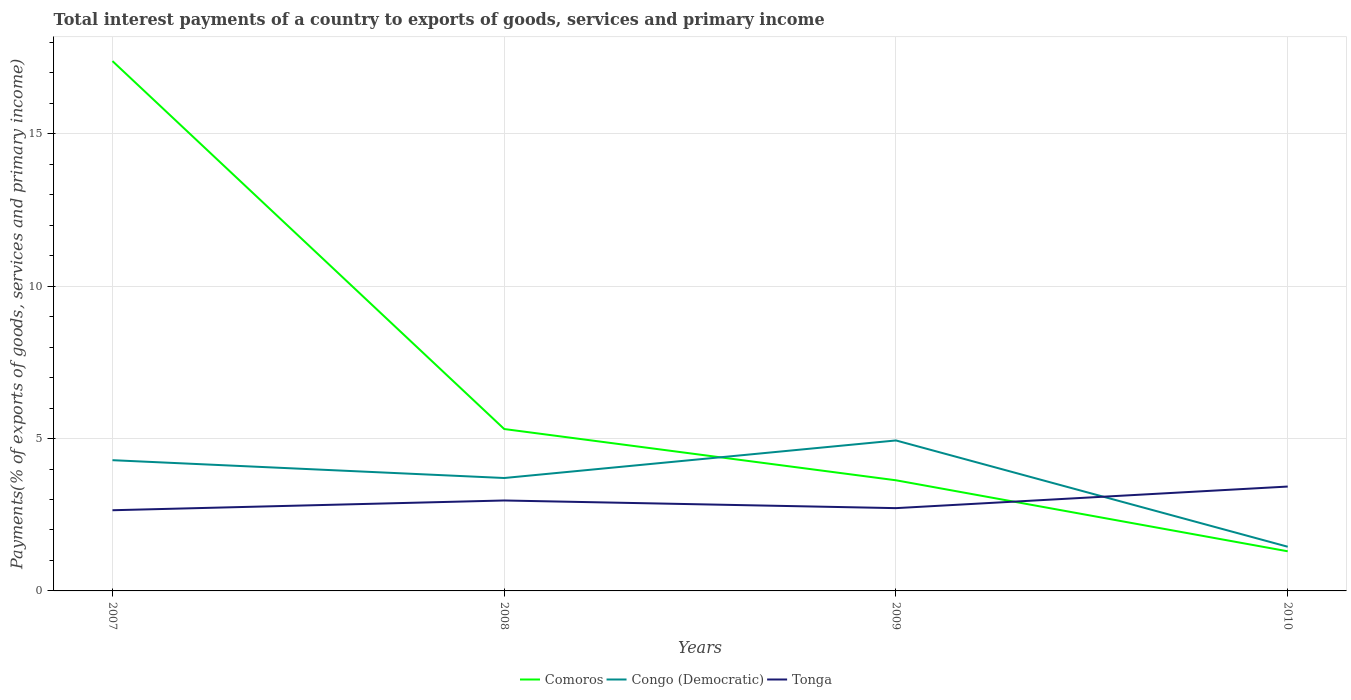How many different coloured lines are there?
Your response must be concise. 3. Is the number of lines equal to the number of legend labels?
Keep it short and to the point. Yes. Across all years, what is the maximum total interest payments in Congo (Democratic)?
Make the answer very short. 1.45. What is the total total interest payments in Comoros in the graph?
Your response must be concise. 4.01. What is the difference between the highest and the second highest total interest payments in Comoros?
Offer a very short reply. 16.09. Is the total interest payments in Tonga strictly greater than the total interest payments in Comoros over the years?
Your answer should be very brief. No. How many years are there in the graph?
Make the answer very short. 4. What is the difference between two consecutive major ticks on the Y-axis?
Keep it short and to the point. 5. Does the graph contain any zero values?
Ensure brevity in your answer.  No. How are the legend labels stacked?
Make the answer very short. Horizontal. What is the title of the graph?
Provide a short and direct response. Total interest payments of a country to exports of goods, services and primary income. Does "Yemen, Rep." appear as one of the legend labels in the graph?
Your answer should be very brief. No. What is the label or title of the X-axis?
Provide a succinct answer. Years. What is the label or title of the Y-axis?
Your answer should be compact. Payments(% of exports of goods, services and primary income). What is the Payments(% of exports of goods, services and primary income) in Comoros in 2007?
Ensure brevity in your answer.  17.39. What is the Payments(% of exports of goods, services and primary income) in Congo (Democratic) in 2007?
Give a very brief answer. 4.29. What is the Payments(% of exports of goods, services and primary income) of Tonga in 2007?
Give a very brief answer. 2.65. What is the Payments(% of exports of goods, services and primary income) in Comoros in 2008?
Offer a terse response. 5.31. What is the Payments(% of exports of goods, services and primary income) of Congo (Democratic) in 2008?
Provide a short and direct response. 3.71. What is the Payments(% of exports of goods, services and primary income) of Tonga in 2008?
Your answer should be very brief. 2.97. What is the Payments(% of exports of goods, services and primary income) of Comoros in 2009?
Your answer should be very brief. 3.63. What is the Payments(% of exports of goods, services and primary income) in Congo (Democratic) in 2009?
Your answer should be compact. 4.94. What is the Payments(% of exports of goods, services and primary income) in Tonga in 2009?
Make the answer very short. 2.72. What is the Payments(% of exports of goods, services and primary income) of Comoros in 2010?
Offer a terse response. 1.3. What is the Payments(% of exports of goods, services and primary income) in Congo (Democratic) in 2010?
Your response must be concise. 1.45. What is the Payments(% of exports of goods, services and primary income) of Tonga in 2010?
Your answer should be very brief. 3.43. Across all years, what is the maximum Payments(% of exports of goods, services and primary income) of Comoros?
Keep it short and to the point. 17.39. Across all years, what is the maximum Payments(% of exports of goods, services and primary income) of Congo (Democratic)?
Your answer should be compact. 4.94. Across all years, what is the maximum Payments(% of exports of goods, services and primary income) in Tonga?
Your response must be concise. 3.43. Across all years, what is the minimum Payments(% of exports of goods, services and primary income) of Comoros?
Make the answer very short. 1.3. Across all years, what is the minimum Payments(% of exports of goods, services and primary income) of Congo (Democratic)?
Offer a terse response. 1.45. Across all years, what is the minimum Payments(% of exports of goods, services and primary income) of Tonga?
Make the answer very short. 2.65. What is the total Payments(% of exports of goods, services and primary income) in Comoros in the graph?
Provide a succinct answer. 27.63. What is the total Payments(% of exports of goods, services and primary income) of Congo (Democratic) in the graph?
Provide a short and direct response. 14.38. What is the total Payments(% of exports of goods, services and primary income) in Tonga in the graph?
Ensure brevity in your answer.  11.76. What is the difference between the Payments(% of exports of goods, services and primary income) of Comoros in 2007 and that in 2008?
Your response must be concise. 12.07. What is the difference between the Payments(% of exports of goods, services and primary income) in Congo (Democratic) in 2007 and that in 2008?
Your answer should be very brief. 0.58. What is the difference between the Payments(% of exports of goods, services and primary income) of Tonga in 2007 and that in 2008?
Offer a terse response. -0.32. What is the difference between the Payments(% of exports of goods, services and primary income) in Comoros in 2007 and that in 2009?
Keep it short and to the point. 13.76. What is the difference between the Payments(% of exports of goods, services and primary income) of Congo (Democratic) in 2007 and that in 2009?
Keep it short and to the point. -0.65. What is the difference between the Payments(% of exports of goods, services and primary income) in Tonga in 2007 and that in 2009?
Make the answer very short. -0.07. What is the difference between the Payments(% of exports of goods, services and primary income) of Comoros in 2007 and that in 2010?
Your answer should be compact. 16.09. What is the difference between the Payments(% of exports of goods, services and primary income) in Congo (Democratic) in 2007 and that in 2010?
Your answer should be compact. 2.84. What is the difference between the Payments(% of exports of goods, services and primary income) of Tonga in 2007 and that in 2010?
Offer a terse response. -0.78. What is the difference between the Payments(% of exports of goods, services and primary income) in Comoros in 2008 and that in 2009?
Ensure brevity in your answer.  1.68. What is the difference between the Payments(% of exports of goods, services and primary income) in Congo (Democratic) in 2008 and that in 2009?
Your answer should be very brief. -1.23. What is the difference between the Payments(% of exports of goods, services and primary income) of Tonga in 2008 and that in 2009?
Your answer should be compact. 0.25. What is the difference between the Payments(% of exports of goods, services and primary income) of Comoros in 2008 and that in 2010?
Provide a short and direct response. 4.01. What is the difference between the Payments(% of exports of goods, services and primary income) in Congo (Democratic) in 2008 and that in 2010?
Offer a very short reply. 2.26. What is the difference between the Payments(% of exports of goods, services and primary income) of Tonga in 2008 and that in 2010?
Your response must be concise. -0.46. What is the difference between the Payments(% of exports of goods, services and primary income) of Comoros in 2009 and that in 2010?
Make the answer very short. 2.33. What is the difference between the Payments(% of exports of goods, services and primary income) of Congo (Democratic) in 2009 and that in 2010?
Your answer should be very brief. 3.49. What is the difference between the Payments(% of exports of goods, services and primary income) of Tonga in 2009 and that in 2010?
Provide a short and direct response. -0.71. What is the difference between the Payments(% of exports of goods, services and primary income) in Comoros in 2007 and the Payments(% of exports of goods, services and primary income) in Congo (Democratic) in 2008?
Your response must be concise. 13.68. What is the difference between the Payments(% of exports of goods, services and primary income) of Comoros in 2007 and the Payments(% of exports of goods, services and primary income) of Tonga in 2008?
Make the answer very short. 14.42. What is the difference between the Payments(% of exports of goods, services and primary income) of Congo (Democratic) in 2007 and the Payments(% of exports of goods, services and primary income) of Tonga in 2008?
Make the answer very short. 1.32. What is the difference between the Payments(% of exports of goods, services and primary income) of Comoros in 2007 and the Payments(% of exports of goods, services and primary income) of Congo (Democratic) in 2009?
Offer a very short reply. 12.45. What is the difference between the Payments(% of exports of goods, services and primary income) of Comoros in 2007 and the Payments(% of exports of goods, services and primary income) of Tonga in 2009?
Offer a very short reply. 14.67. What is the difference between the Payments(% of exports of goods, services and primary income) of Congo (Democratic) in 2007 and the Payments(% of exports of goods, services and primary income) of Tonga in 2009?
Provide a short and direct response. 1.57. What is the difference between the Payments(% of exports of goods, services and primary income) of Comoros in 2007 and the Payments(% of exports of goods, services and primary income) of Congo (Democratic) in 2010?
Provide a succinct answer. 15.94. What is the difference between the Payments(% of exports of goods, services and primary income) in Comoros in 2007 and the Payments(% of exports of goods, services and primary income) in Tonga in 2010?
Provide a short and direct response. 13.96. What is the difference between the Payments(% of exports of goods, services and primary income) of Congo (Democratic) in 2007 and the Payments(% of exports of goods, services and primary income) of Tonga in 2010?
Offer a terse response. 0.87. What is the difference between the Payments(% of exports of goods, services and primary income) in Comoros in 2008 and the Payments(% of exports of goods, services and primary income) in Congo (Democratic) in 2009?
Provide a succinct answer. 0.37. What is the difference between the Payments(% of exports of goods, services and primary income) of Comoros in 2008 and the Payments(% of exports of goods, services and primary income) of Tonga in 2009?
Offer a terse response. 2.6. What is the difference between the Payments(% of exports of goods, services and primary income) of Comoros in 2008 and the Payments(% of exports of goods, services and primary income) of Congo (Democratic) in 2010?
Give a very brief answer. 3.86. What is the difference between the Payments(% of exports of goods, services and primary income) in Comoros in 2008 and the Payments(% of exports of goods, services and primary income) in Tonga in 2010?
Keep it short and to the point. 1.89. What is the difference between the Payments(% of exports of goods, services and primary income) of Congo (Democratic) in 2008 and the Payments(% of exports of goods, services and primary income) of Tonga in 2010?
Keep it short and to the point. 0.28. What is the difference between the Payments(% of exports of goods, services and primary income) in Comoros in 2009 and the Payments(% of exports of goods, services and primary income) in Congo (Democratic) in 2010?
Provide a short and direct response. 2.18. What is the difference between the Payments(% of exports of goods, services and primary income) of Comoros in 2009 and the Payments(% of exports of goods, services and primary income) of Tonga in 2010?
Offer a terse response. 0.21. What is the difference between the Payments(% of exports of goods, services and primary income) of Congo (Democratic) in 2009 and the Payments(% of exports of goods, services and primary income) of Tonga in 2010?
Provide a succinct answer. 1.51. What is the average Payments(% of exports of goods, services and primary income) in Comoros per year?
Provide a short and direct response. 6.91. What is the average Payments(% of exports of goods, services and primary income) in Congo (Democratic) per year?
Keep it short and to the point. 3.6. What is the average Payments(% of exports of goods, services and primary income) of Tonga per year?
Make the answer very short. 2.94. In the year 2007, what is the difference between the Payments(% of exports of goods, services and primary income) of Comoros and Payments(% of exports of goods, services and primary income) of Congo (Democratic)?
Provide a short and direct response. 13.1. In the year 2007, what is the difference between the Payments(% of exports of goods, services and primary income) of Comoros and Payments(% of exports of goods, services and primary income) of Tonga?
Make the answer very short. 14.74. In the year 2007, what is the difference between the Payments(% of exports of goods, services and primary income) in Congo (Democratic) and Payments(% of exports of goods, services and primary income) in Tonga?
Offer a very short reply. 1.64. In the year 2008, what is the difference between the Payments(% of exports of goods, services and primary income) in Comoros and Payments(% of exports of goods, services and primary income) in Congo (Democratic)?
Offer a very short reply. 1.61. In the year 2008, what is the difference between the Payments(% of exports of goods, services and primary income) of Comoros and Payments(% of exports of goods, services and primary income) of Tonga?
Give a very brief answer. 2.35. In the year 2008, what is the difference between the Payments(% of exports of goods, services and primary income) of Congo (Democratic) and Payments(% of exports of goods, services and primary income) of Tonga?
Give a very brief answer. 0.74. In the year 2009, what is the difference between the Payments(% of exports of goods, services and primary income) of Comoros and Payments(% of exports of goods, services and primary income) of Congo (Democratic)?
Give a very brief answer. -1.31. In the year 2009, what is the difference between the Payments(% of exports of goods, services and primary income) of Comoros and Payments(% of exports of goods, services and primary income) of Tonga?
Give a very brief answer. 0.91. In the year 2009, what is the difference between the Payments(% of exports of goods, services and primary income) of Congo (Democratic) and Payments(% of exports of goods, services and primary income) of Tonga?
Make the answer very short. 2.22. In the year 2010, what is the difference between the Payments(% of exports of goods, services and primary income) of Comoros and Payments(% of exports of goods, services and primary income) of Congo (Democratic)?
Provide a short and direct response. -0.15. In the year 2010, what is the difference between the Payments(% of exports of goods, services and primary income) in Comoros and Payments(% of exports of goods, services and primary income) in Tonga?
Your response must be concise. -2.12. In the year 2010, what is the difference between the Payments(% of exports of goods, services and primary income) in Congo (Democratic) and Payments(% of exports of goods, services and primary income) in Tonga?
Give a very brief answer. -1.97. What is the ratio of the Payments(% of exports of goods, services and primary income) in Comoros in 2007 to that in 2008?
Provide a short and direct response. 3.27. What is the ratio of the Payments(% of exports of goods, services and primary income) in Congo (Democratic) in 2007 to that in 2008?
Offer a terse response. 1.16. What is the ratio of the Payments(% of exports of goods, services and primary income) in Tonga in 2007 to that in 2008?
Ensure brevity in your answer.  0.89. What is the ratio of the Payments(% of exports of goods, services and primary income) in Comoros in 2007 to that in 2009?
Ensure brevity in your answer.  4.79. What is the ratio of the Payments(% of exports of goods, services and primary income) of Congo (Democratic) in 2007 to that in 2009?
Offer a terse response. 0.87. What is the ratio of the Payments(% of exports of goods, services and primary income) of Tonga in 2007 to that in 2009?
Provide a succinct answer. 0.97. What is the ratio of the Payments(% of exports of goods, services and primary income) of Comoros in 2007 to that in 2010?
Your answer should be compact. 13.37. What is the ratio of the Payments(% of exports of goods, services and primary income) of Congo (Democratic) in 2007 to that in 2010?
Ensure brevity in your answer.  2.96. What is the ratio of the Payments(% of exports of goods, services and primary income) of Tonga in 2007 to that in 2010?
Keep it short and to the point. 0.77. What is the ratio of the Payments(% of exports of goods, services and primary income) of Comoros in 2008 to that in 2009?
Provide a short and direct response. 1.46. What is the ratio of the Payments(% of exports of goods, services and primary income) of Congo (Democratic) in 2008 to that in 2009?
Your answer should be compact. 0.75. What is the ratio of the Payments(% of exports of goods, services and primary income) in Tonga in 2008 to that in 2009?
Your answer should be very brief. 1.09. What is the ratio of the Payments(% of exports of goods, services and primary income) of Comoros in 2008 to that in 2010?
Your answer should be very brief. 4.09. What is the ratio of the Payments(% of exports of goods, services and primary income) in Congo (Democratic) in 2008 to that in 2010?
Offer a very short reply. 2.56. What is the ratio of the Payments(% of exports of goods, services and primary income) in Tonga in 2008 to that in 2010?
Give a very brief answer. 0.87. What is the ratio of the Payments(% of exports of goods, services and primary income) in Comoros in 2009 to that in 2010?
Your answer should be very brief. 2.79. What is the ratio of the Payments(% of exports of goods, services and primary income) in Congo (Democratic) in 2009 to that in 2010?
Offer a terse response. 3.41. What is the ratio of the Payments(% of exports of goods, services and primary income) in Tonga in 2009 to that in 2010?
Your answer should be compact. 0.79. What is the difference between the highest and the second highest Payments(% of exports of goods, services and primary income) of Comoros?
Ensure brevity in your answer.  12.07. What is the difference between the highest and the second highest Payments(% of exports of goods, services and primary income) of Congo (Democratic)?
Your answer should be compact. 0.65. What is the difference between the highest and the second highest Payments(% of exports of goods, services and primary income) of Tonga?
Make the answer very short. 0.46. What is the difference between the highest and the lowest Payments(% of exports of goods, services and primary income) in Comoros?
Make the answer very short. 16.09. What is the difference between the highest and the lowest Payments(% of exports of goods, services and primary income) in Congo (Democratic)?
Keep it short and to the point. 3.49. What is the difference between the highest and the lowest Payments(% of exports of goods, services and primary income) of Tonga?
Provide a succinct answer. 0.78. 